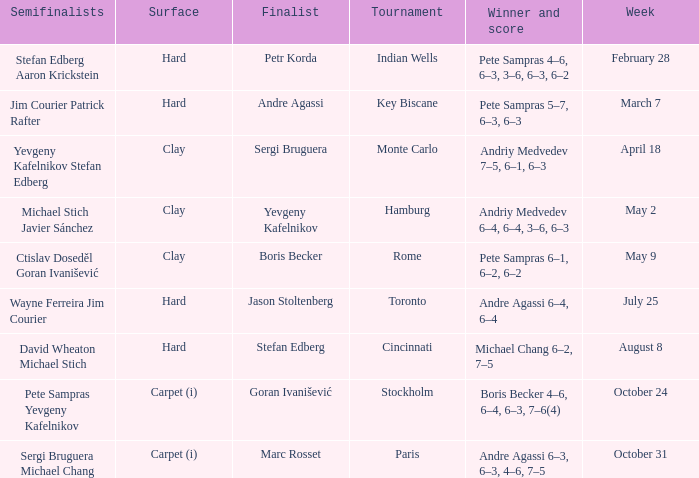Could you parse the entire table? {'header': ['Semifinalists', 'Surface', 'Finalist', 'Tournament', 'Winner and score', 'Week'], 'rows': [['Stefan Edberg Aaron Krickstein', 'Hard', 'Petr Korda', 'Indian Wells', 'Pete Sampras 4–6, 6–3, 3–6, 6–3, 6–2', 'February 28'], ['Jim Courier Patrick Rafter', 'Hard', 'Andre Agassi', 'Key Biscane', 'Pete Sampras 5–7, 6–3, 6–3', 'March 7'], ['Yevgeny Kafelnikov Stefan Edberg', 'Clay', 'Sergi Bruguera', 'Monte Carlo', 'Andriy Medvedev 7–5, 6–1, 6–3', 'April 18'], ['Michael Stich Javier Sánchez', 'Clay', 'Yevgeny Kafelnikov', 'Hamburg', 'Andriy Medvedev 6–4, 6–4, 3–6, 6–3', 'May 2'], ['Ctislav Doseděl Goran Ivanišević', 'Clay', 'Boris Becker', 'Rome', 'Pete Sampras 6–1, 6–2, 6–2', 'May 9'], ['Wayne Ferreira Jim Courier', 'Hard', 'Jason Stoltenberg', 'Toronto', 'Andre Agassi 6–4, 6–4', 'July 25'], ['David Wheaton Michael Stich', 'Hard', 'Stefan Edberg', 'Cincinnati', 'Michael Chang 6–2, 7–5', 'August 8'], ['Pete Sampras Yevgeny Kafelnikov', 'Carpet (i)', 'Goran Ivanišević', 'Stockholm', 'Boris Becker 4–6, 6–4, 6–3, 7–6(4)', 'October 24'], ['Sergi Bruguera Michael Chang', 'Carpet (i)', 'Marc Rosset', 'Paris', 'Andre Agassi 6–3, 6–3, 4–6, 7–5', 'October 31']]} Who was the semifinalist for the key biscane tournament? Jim Courier Patrick Rafter. 